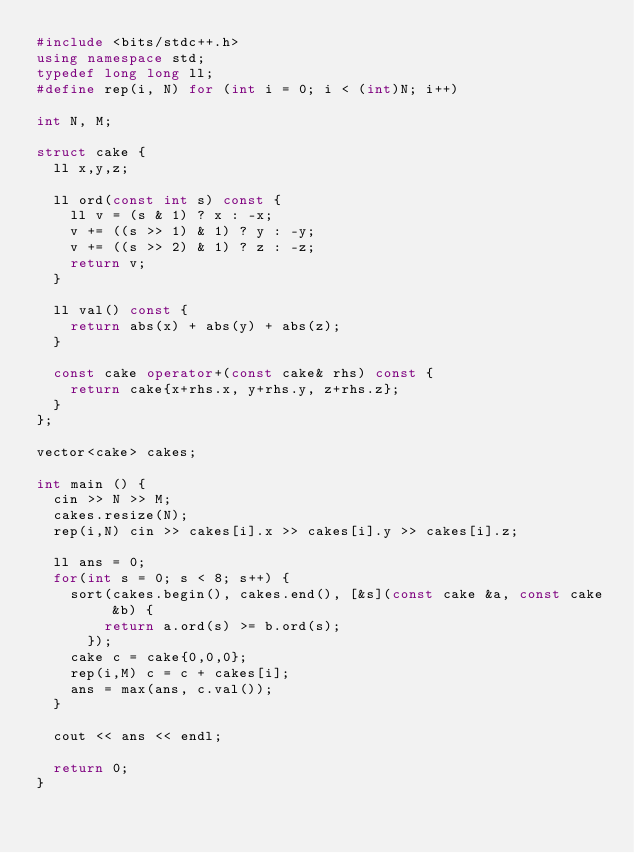Convert code to text. <code><loc_0><loc_0><loc_500><loc_500><_C++_>#include <bits/stdc++.h>
using namespace std;
typedef long long ll;
#define rep(i, N) for (int i = 0; i < (int)N; i++)

int N, M;

struct cake {
  ll x,y,z;

  ll ord(const int s) const {
    ll v = (s & 1) ? x : -x;
    v += ((s >> 1) & 1) ? y : -y;
    v += ((s >> 2) & 1) ? z : -z;
    return v;
  }

  ll val() const {
    return abs(x) + abs(y) + abs(z);
  }

  const cake operator+(const cake& rhs) const {
    return cake{x+rhs.x, y+rhs.y, z+rhs.z};
  }
};

vector<cake> cakes;

int main () {
  cin >> N >> M;
  cakes.resize(N);
  rep(i,N) cin >> cakes[i].x >> cakes[i].y >> cakes[i].z;

  ll ans = 0;
  for(int s = 0; s < 8; s++) {
    sort(cakes.begin(), cakes.end(), [&s](const cake &a, const cake &b) {
        return a.ord(s) >= b.ord(s);
      });
    cake c = cake{0,0,0};
    rep(i,M) c = c + cakes[i];
    ans = max(ans, c.val());
  }

  cout << ans << endl;

  return 0;
}
</code> 